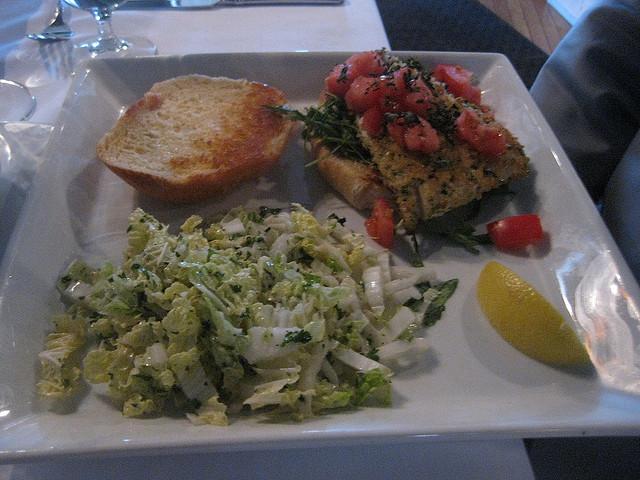What is the food item with the green colors?
Answer briefly. Lettuce. How many pieces is the sandwich cut into?
Short answer required. 1. What kind of meat is on the plate?
Concise answer only. Fish. Can you see French fries?
Write a very short answer. No. What color is the plate?
Short answer required. White. 